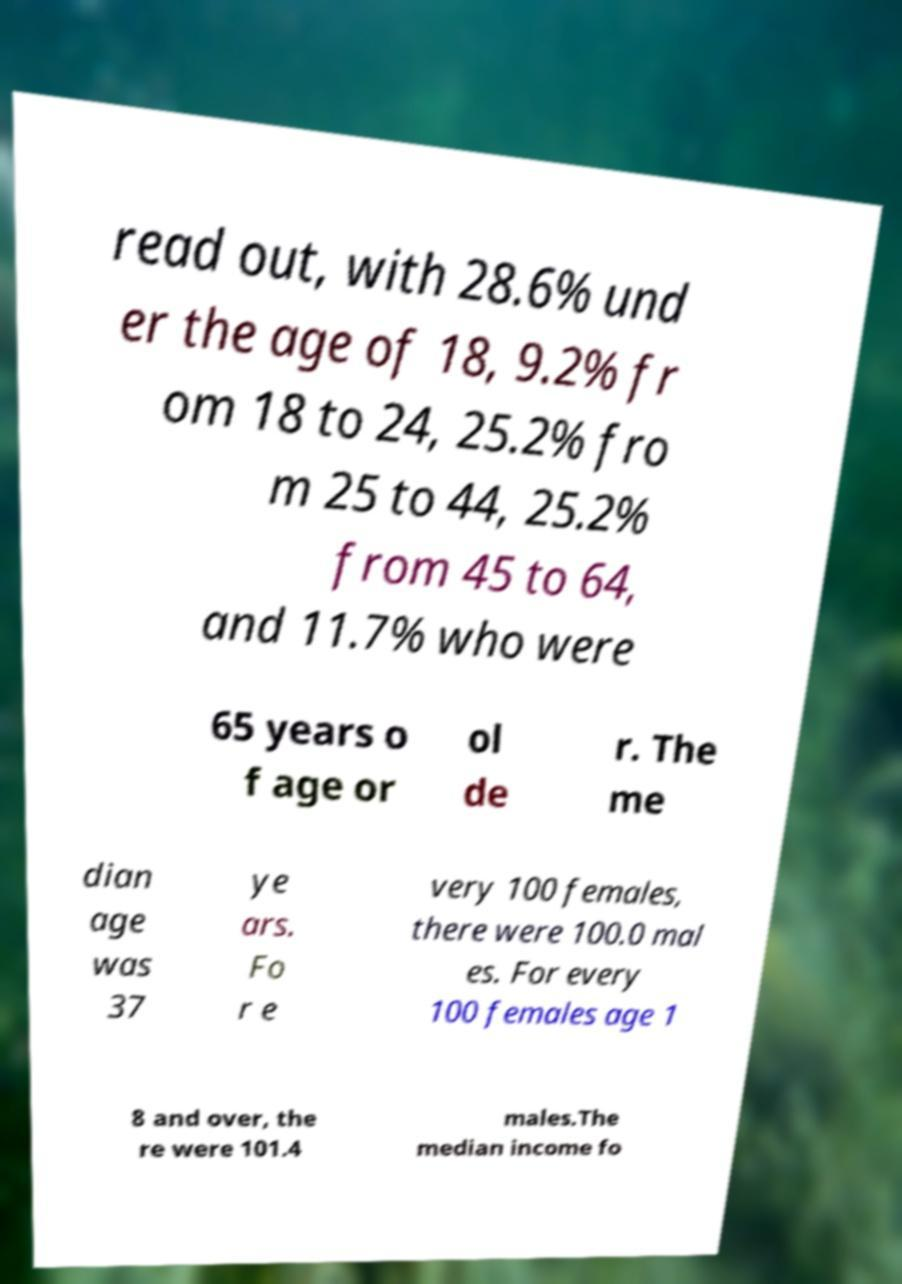What messages or text are displayed in this image? I need them in a readable, typed format. read out, with 28.6% und er the age of 18, 9.2% fr om 18 to 24, 25.2% fro m 25 to 44, 25.2% from 45 to 64, and 11.7% who were 65 years o f age or ol de r. The me dian age was 37 ye ars. Fo r e very 100 females, there were 100.0 mal es. For every 100 females age 1 8 and over, the re were 101.4 males.The median income fo 